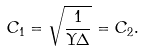Convert formula to latex. <formula><loc_0><loc_0><loc_500><loc_500>C _ { 1 } = \sqrt { \frac { 1 } { \Upsilon \Delta } } = C _ { 2 } .</formula> 